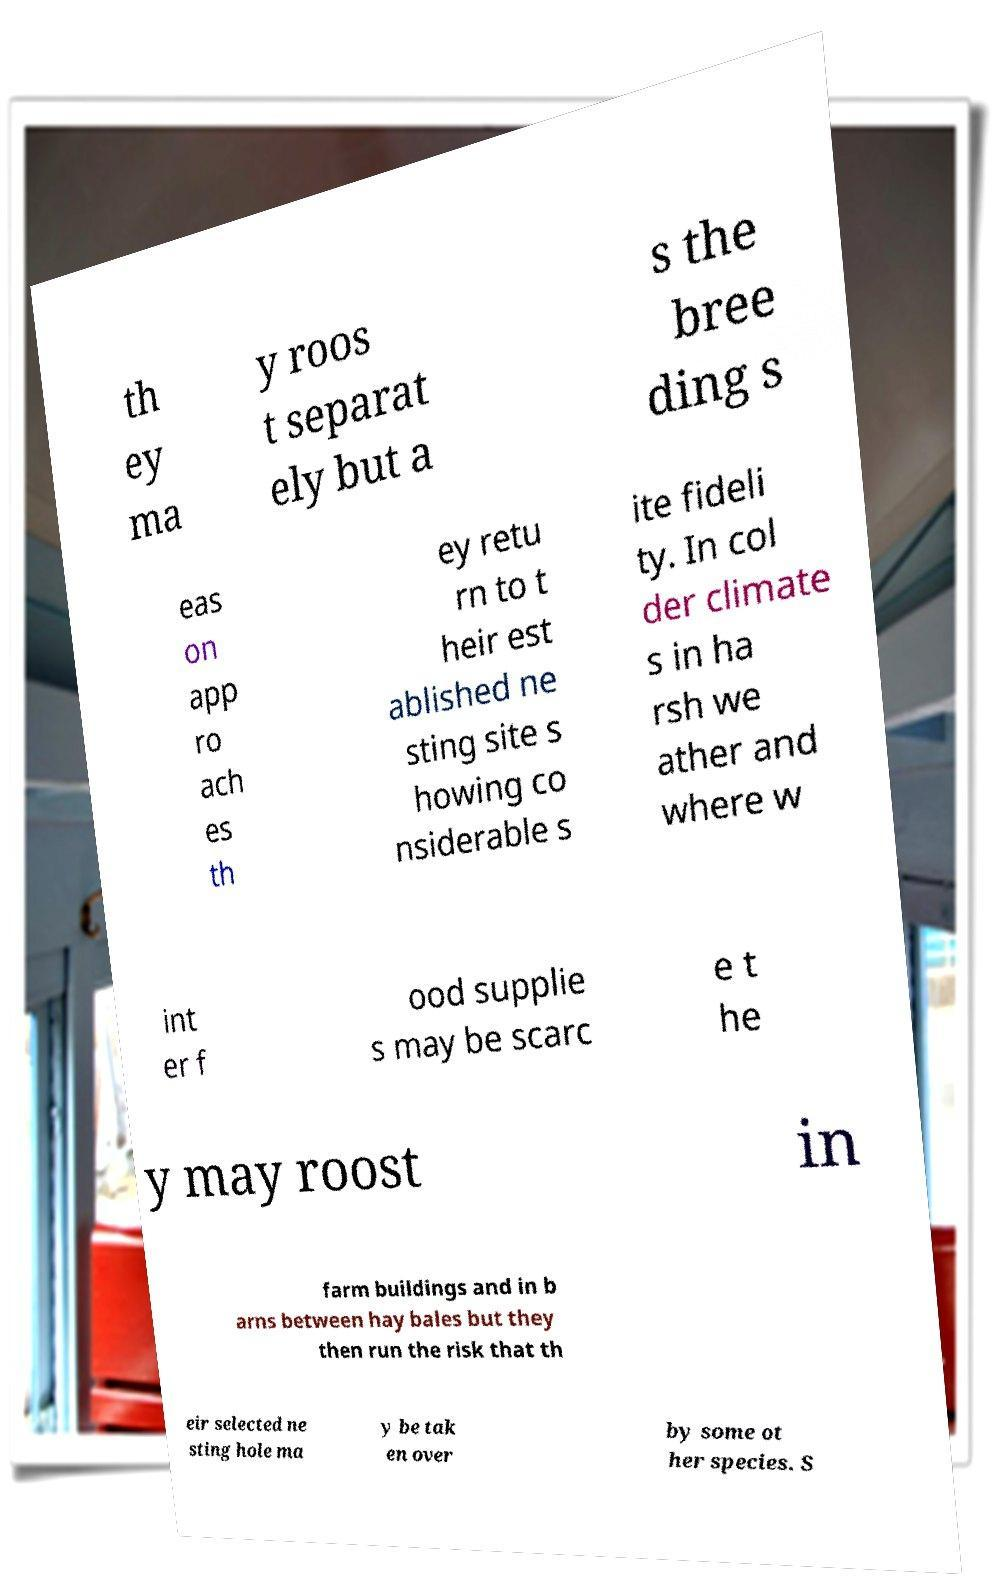Could you assist in decoding the text presented in this image and type it out clearly? th ey ma y roos t separat ely but a s the bree ding s eas on app ro ach es th ey retu rn to t heir est ablished ne sting site s howing co nsiderable s ite fideli ty. In col der climate s in ha rsh we ather and where w int er f ood supplie s may be scarc e t he y may roost in farm buildings and in b arns between hay bales but they then run the risk that th eir selected ne sting hole ma y be tak en over by some ot her species. S 